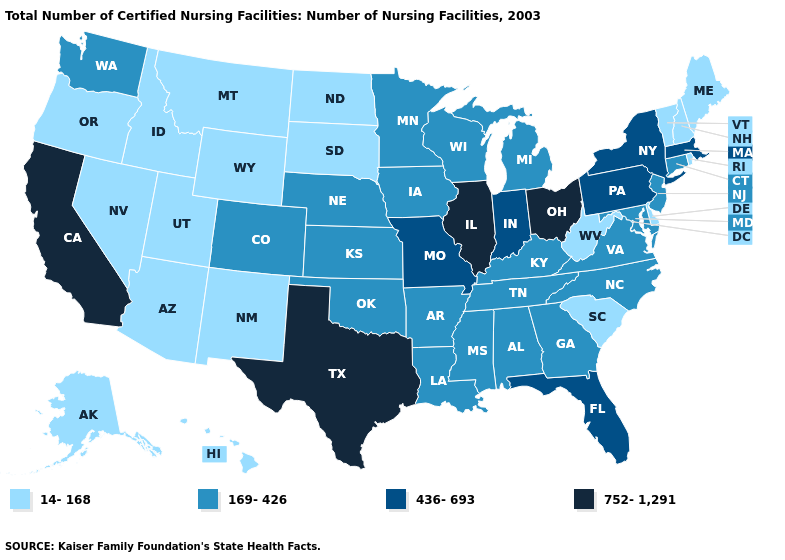What is the value of Wisconsin?
Be succinct. 169-426. Does Texas have the highest value in the South?
Short answer required. Yes. What is the value of Ohio?
Quick response, please. 752-1,291. What is the value of Oregon?
Short answer required. 14-168. Does the first symbol in the legend represent the smallest category?
Short answer required. Yes. Among the states that border New Mexico , which have the highest value?
Short answer required. Texas. What is the lowest value in the USA?
Concise answer only. 14-168. What is the value of North Dakota?
Give a very brief answer. 14-168. Does the map have missing data?
Concise answer only. No. What is the highest value in the West ?
Be succinct. 752-1,291. What is the lowest value in states that border New Mexico?
Give a very brief answer. 14-168. What is the lowest value in the USA?
Quick response, please. 14-168. What is the value of Maryland?
Write a very short answer. 169-426. What is the value of New York?
Quick response, please. 436-693. Name the states that have a value in the range 752-1,291?
Write a very short answer. California, Illinois, Ohio, Texas. 